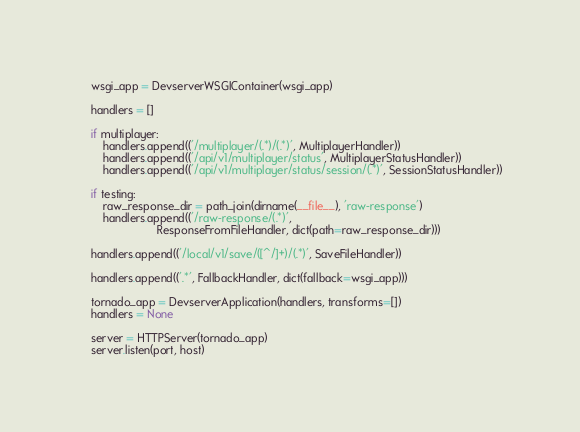Convert code to text. <code><loc_0><loc_0><loc_500><loc_500><_Python_>
    wsgi_app = DevserverWSGIContainer(wsgi_app)

    handlers = []

    if multiplayer:
        handlers.append(('/multiplayer/(.*)/(.*)', MultiplayerHandler))
        handlers.append(('/api/v1/multiplayer/status', MultiplayerStatusHandler))
        handlers.append(('/api/v1/multiplayer/status/session/(.*)', SessionStatusHandler))

    if testing:
        raw_response_dir = path_join(dirname(__file__), 'raw-response')
        handlers.append(('/raw-response/(.*)',
                         ResponseFromFileHandler, dict(path=raw_response_dir)))

    handlers.append(('/local/v1/save/([^/]+)/(.*)', SaveFileHandler))

    handlers.append(('.*', FallbackHandler, dict(fallback=wsgi_app)))

    tornado_app = DevserverApplication(handlers, transforms=[])
    handlers = None

    server = HTTPServer(tornado_app)
    server.listen(port, host)
</code> 